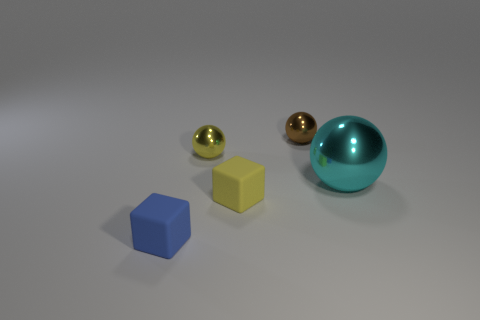What is the material of the blue block?
Your response must be concise. Rubber. What is the color of the thing that is made of the same material as the blue cube?
Your response must be concise. Yellow. Are there any large shiny things on the left side of the sphere in front of the small yellow metallic object?
Keep it short and to the point. No. How many other objects are the same shape as the brown object?
Keep it short and to the point. 2. Is the shape of the metallic object left of the tiny brown shiny object the same as the tiny yellow object in front of the cyan sphere?
Your response must be concise. No. There is a yellow thing in front of the metallic ball right of the small brown ball; what number of tiny yellow metal objects are in front of it?
Offer a terse response. 0. What is the color of the large metal sphere?
Offer a very short reply. Cyan. What number of other things are the same size as the brown shiny thing?
Offer a very short reply. 3. There is a small blue object that is the same shape as the tiny yellow rubber thing; what is it made of?
Offer a very short reply. Rubber. The small block right of the block in front of the yellow thing in front of the big shiny thing is made of what material?
Your answer should be very brief. Rubber. 